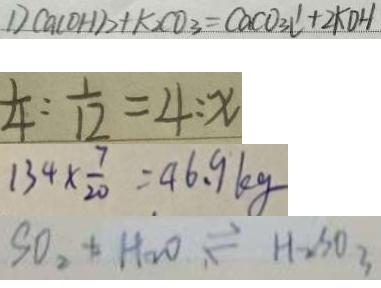Convert formula to latex. <formula><loc_0><loc_0><loc_500><loc_500>D C a ( O H ) _ { 2 } + k _ { 2 } C O _ { 3 } = C a C O _ { 3 } l ^ { \prime } + 2 K D H 
 \frac { 1 } { 4 } : \frac { 1 } { 1 2 } = 4 : x 
 1 3 4 \times \frac { 7 } { 2 0 } = 4 6 . 9 k g 
 S O _ { 2 } + H _ { 2 } O \rightleftharpoons H _ { 2 } S 0 _ { 3 }</formula> 